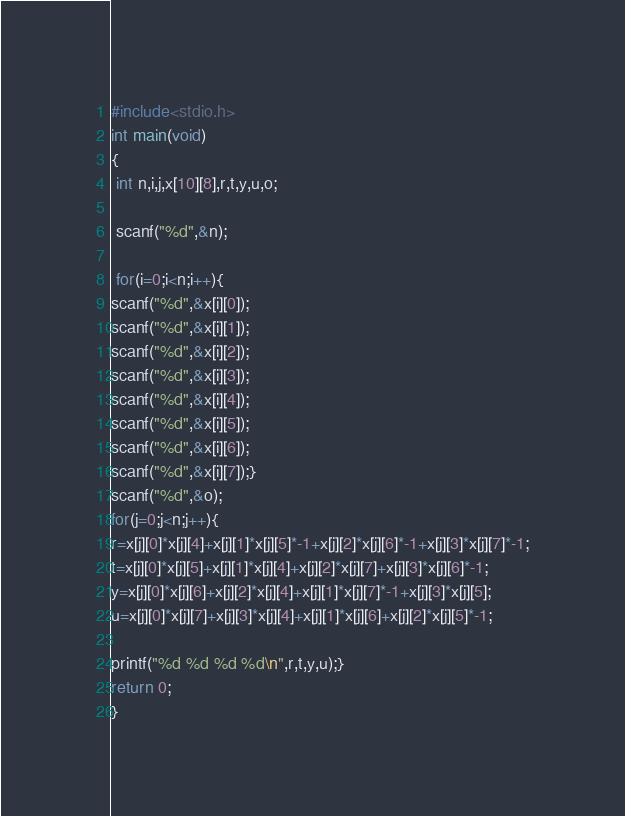Convert code to text. <code><loc_0><loc_0><loc_500><loc_500><_C_>#include<stdio.h>
int main(void)
{
 int n,i,j,x[10][8],r,t,y,u,o;

 scanf("%d",&n);

 for(i=0;i<n;i++){
scanf("%d",&x[i][0]);
scanf("%d",&x[i][1]);
scanf("%d",&x[i][2]);
scanf("%d",&x[i][3]);
scanf("%d",&x[i][4]);
scanf("%d",&x[i][5]);
scanf("%d",&x[i][6]);
scanf("%d",&x[i][7]);}
scanf("%d",&o);
for(j=0;j<n;j++){
r=x[j][0]*x[j][4]+x[j][1]*x[j][5]*-1+x[j][2]*x[j][6]*-1+x[j][3]*x[j][7]*-1;
t=x[j][0]*x[j][5]+x[j][1]*x[j][4]+x[j][2]*x[j][7]+x[j][3]*x[j][6]*-1;
y=x[j][0]*x[j][6]+x[j][2]*x[j][4]+x[j][1]*x[j][7]*-1+x[j][3]*x[j][5];
u=x[j][0]*x[j][7]+x[j][3]*x[j][4]+x[j][1]*x[j][6]+x[j][2]*x[j][5]*-1;

printf("%d %d %d %d\n",r,t,y,u);}
return 0;
}

</code> 